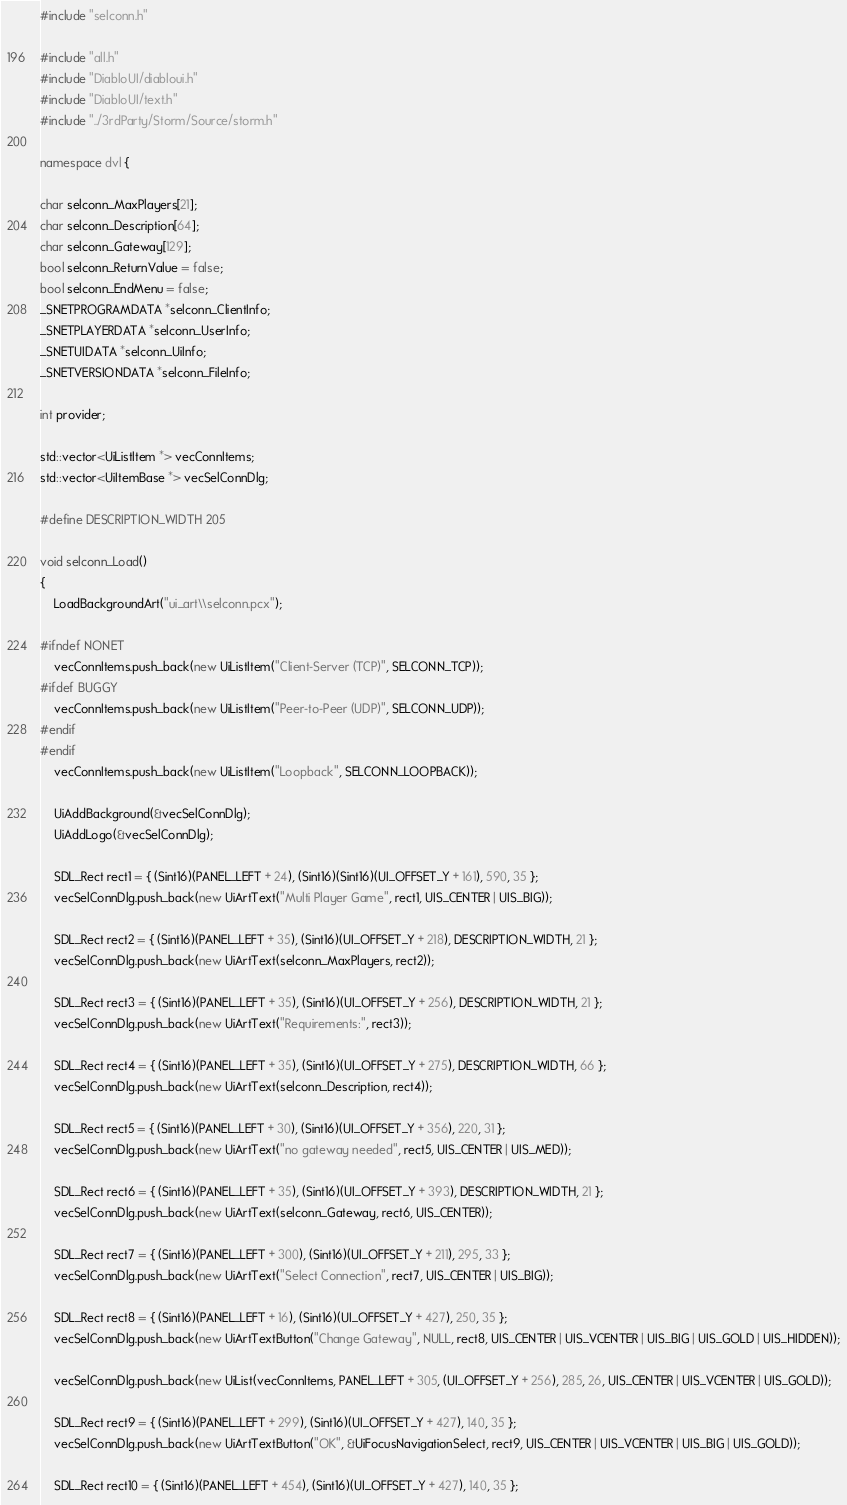Convert code to text. <code><loc_0><loc_0><loc_500><loc_500><_C++_>#include "selconn.h"

#include "all.h"
#include "DiabloUI/diabloui.h"
#include "DiabloUI/text.h"
#include "../3rdParty/Storm/Source/storm.h"

namespace dvl {

char selconn_MaxPlayers[21];
char selconn_Description[64];
char selconn_Gateway[129];
bool selconn_ReturnValue = false;
bool selconn_EndMenu = false;
_SNETPROGRAMDATA *selconn_ClientInfo;
_SNETPLAYERDATA *selconn_UserInfo;
_SNETUIDATA *selconn_UiInfo;
_SNETVERSIONDATA *selconn_FileInfo;

int provider;

std::vector<UiListItem *> vecConnItems;
std::vector<UiItemBase *> vecSelConnDlg;

#define DESCRIPTION_WIDTH 205

void selconn_Load()
{
	LoadBackgroundArt("ui_art\\selconn.pcx");

#ifndef NONET
	vecConnItems.push_back(new UiListItem("Client-Server (TCP)", SELCONN_TCP));
#ifdef BUGGY
	vecConnItems.push_back(new UiListItem("Peer-to-Peer (UDP)", SELCONN_UDP));
#endif
#endif
	vecConnItems.push_back(new UiListItem("Loopback", SELCONN_LOOPBACK));

	UiAddBackground(&vecSelConnDlg);
	UiAddLogo(&vecSelConnDlg);

	SDL_Rect rect1 = { (Sint16)(PANEL_LEFT + 24), (Sint16)(Sint16)(UI_OFFSET_Y + 161), 590, 35 };
	vecSelConnDlg.push_back(new UiArtText("Multi Player Game", rect1, UIS_CENTER | UIS_BIG));

	SDL_Rect rect2 = { (Sint16)(PANEL_LEFT + 35), (Sint16)(UI_OFFSET_Y + 218), DESCRIPTION_WIDTH, 21 };
	vecSelConnDlg.push_back(new UiArtText(selconn_MaxPlayers, rect2));

	SDL_Rect rect3 = { (Sint16)(PANEL_LEFT + 35), (Sint16)(UI_OFFSET_Y + 256), DESCRIPTION_WIDTH, 21 };
	vecSelConnDlg.push_back(new UiArtText("Requirements:", rect3));

	SDL_Rect rect4 = { (Sint16)(PANEL_LEFT + 35), (Sint16)(UI_OFFSET_Y + 275), DESCRIPTION_WIDTH, 66 };
	vecSelConnDlg.push_back(new UiArtText(selconn_Description, rect4));

	SDL_Rect rect5 = { (Sint16)(PANEL_LEFT + 30), (Sint16)(UI_OFFSET_Y + 356), 220, 31 };
	vecSelConnDlg.push_back(new UiArtText("no gateway needed", rect5, UIS_CENTER | UIS_MED));

	SDL_Rect rect6 = { (Sint16)(PANEL_LEFT + 35), (Sint16)(UI_OFFSET_Y + 393), DESCRIPTION_WIDTH, 21 };
	vecSelConnDlg.push_back(new UiArtText(selconn_Gateway, rect6, UIS_CENTER));

	SDL_Rect rect7 = { (Sint16)(PANEL_LEFT + 300), (Sint16)(UI_OFFSET_Y + 211), 295, 33 };
	vecSelConnDlg.push_back(new UiArtText("Select Connection", rect7, UIS_CENTER | UIS_BIG));

	SDL_Rect rect8 = { (Sint16)(PANEL_LEFT + 16), (Sint16)(UI_OFFSET_Y + 427), 250, 35 };
	vecSelConnDlg.push_back(new UiArtTextButton("Change Gateway", NULL, rect8, UIS_CENTER | UIS_VCENTER | UIS_BIG | UIS_GOLD | UIS_HIDDEN));

	vecSelConnDlg.push_back(new UiList(vecConnItems, PANEL_LEFT + 305, (UI_OFFSET_Y + 256), 285, 26, UIS_CENTER | UIS_VCENTER | UIS_GOLD));

	SDL_Rect rect9 = { (Sint16)(PANEL_LEFT + 299), (Sint16)(UI_OFFSET_Y + 427), 140, 35 };
	vecSelConnDlg.push_back(new UiArtTextButton("OK", &UiFocusNavigationSelect, rect9, UIS_CENTER | UIS_VCENTER | UIS_BIG | UIS_GOLD));

	SDL_Rect rect10 = { (Sint16)(PANEL_LEFT + 454), (Sint16)(UI_OFFSET_Y + 427), 140, 35 };</code> 